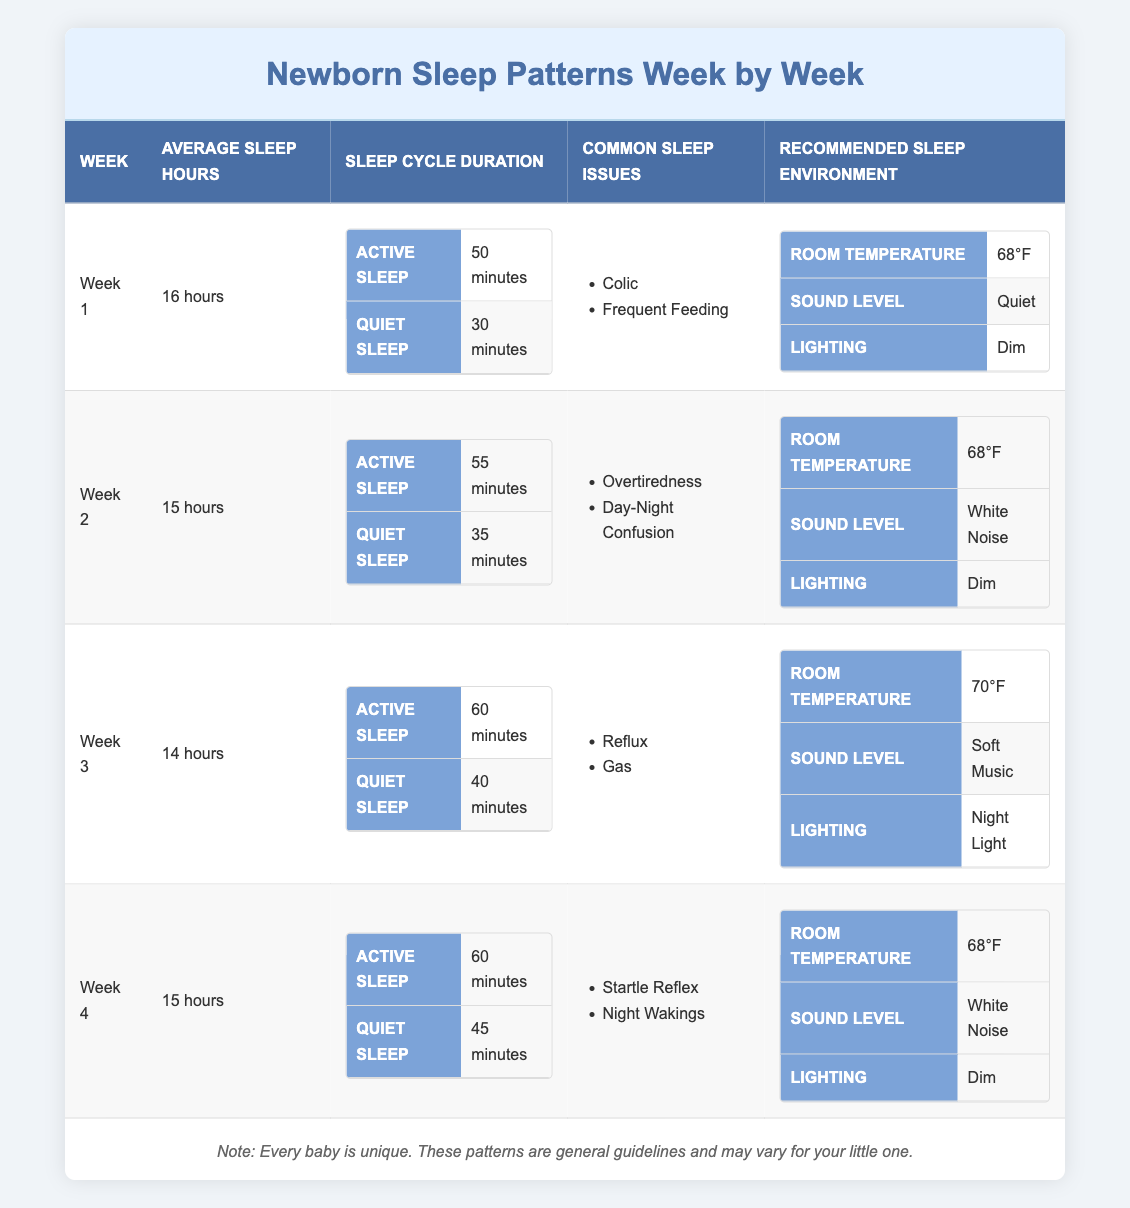What is the average sleep duration for a newborn in Week 2? The table indicates that in Week 2, the average sleep hours are listed as 15 hours.
Answer: 15 hours How long is the active sleep duration in Week 1? The table shows that in Week 1, the active sleep duration is specified as 50 minutes.
Answer: 50 minutes Are common sleep issues the same in Weeks 1 and 2? In Week 1, the common sleep issues are colic and frequent feeding, while in Week 2, they are overtiredness and day-night confusion. Since these lists differ, the answer is no.
Answer: No What is the total average sleep time over the first four weeks? The average sleep hours for the weeks are 16, 15, 14, and 15 hours, respectively. Their total is 16 + 15 + 14 + 15 = 60 hours. Then, to find the average, divide by 4, which gives 60/4 = 15 hours.
Answer: 15 hours Do newborns tend to have longer quiet sleep in Week 3 than in Week 1? In Week 3, the quiet sleep duration is recorded at 40 minutes, and in Week 1, it is 30 minutes. Since 40 minutes (Week 3) is greater than 30 minutes (Week 1), the answer is yes.
Answer: Yes How does the recommended room temperature change from Week 3 to Week 4? The recommended room temperature for Week 3 is 70°F, while for Week 4, it declines to 68°F. This shows a change of 2°F lower in Week 4 compared to Week 3.
Answer: 2°F lower What are the sleep issues reported in Week 4? The table lists the common sleep issues for Week 4 as startle reflex and night wakings, which can be directly found in the respective section of the table.
Answer: Startle reflex, night wakings What is the difference in average sleep hours between Week 1 and Week 3? In Week 1, the average sleep is 16 hours, and in Week 3, it is 14 hours. The difference is calculated by subtracting: 16 - 14 = 2 hours.
Answer: 2 hours Is the lighting setting for the recommended sleep environment the same in Week 2 and Week 4? In Week 2, the lighting is described as dim, and in Week 4, it remains the same as dim as well. Since both are dim, the answer is yes.
Answer: Yes 